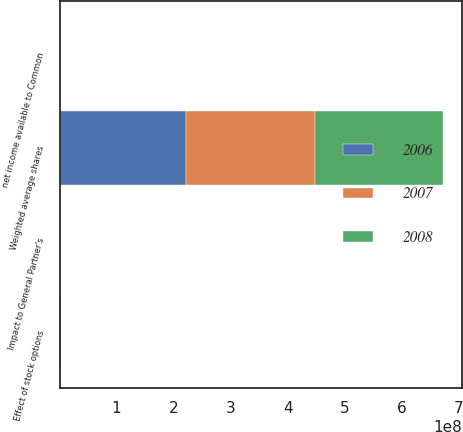<chart> <loc_0><loc_0><loc_500><loc_500><stacked_bar_chart><ecel><fcel>net income available to Common<fcel>Impact to General Partner's<fcel>Weighted average shares<fcel>Effect of stock options<nl><fcel>2007<fcel>422726<fcel>209<fcel>2.25884e+08<fcel>551057<nl><fcel>2008<fcel>436477<fcel>313<fcel>2.23777e+08<fcel>778471<nl><fcel>2006<fcel>486560<fcel>415<fcel>2.21927e+08<fcel>903255<nl></chart> 